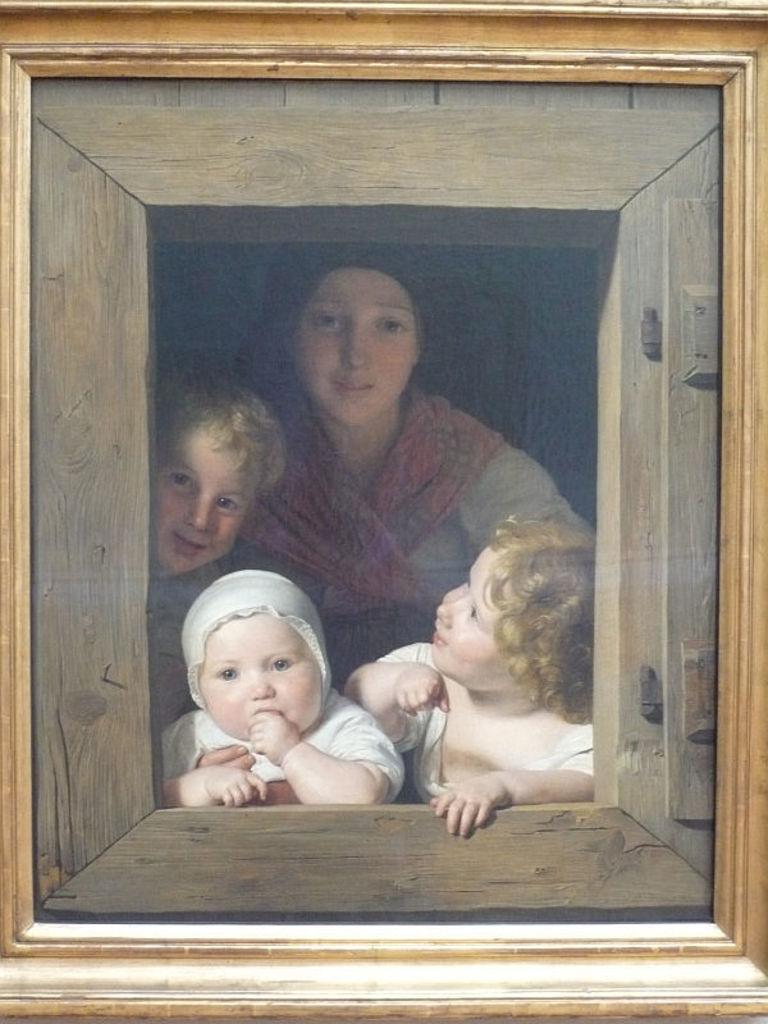Describe this image in one or two sentences. In this image we can see a painting of a person and three kids and the frame is of gold and wooden color. 